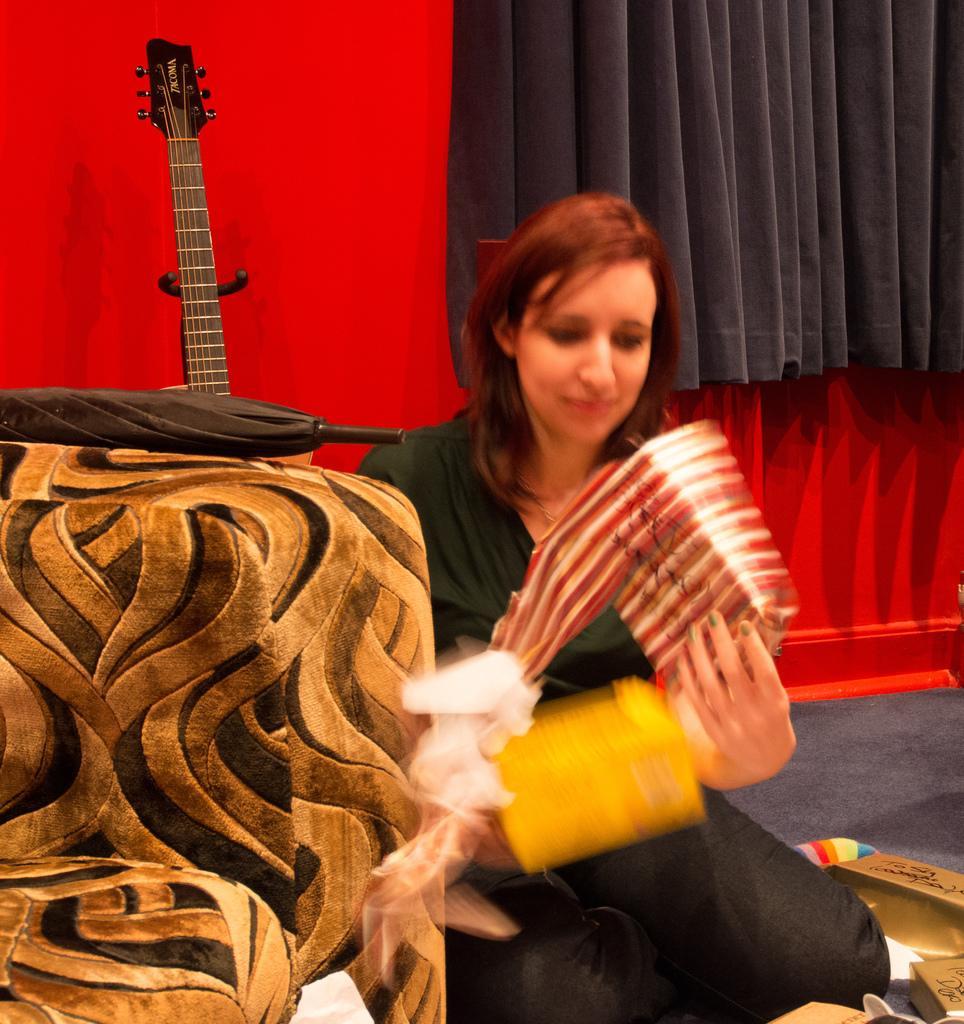How would you summarize this image in a sentence or two? In this image I can see a woman is holding an object in hand, guitar, umbrella and a sofa chair. In the background I can see a wall and a curtain. This image is taken may be in a hall. 